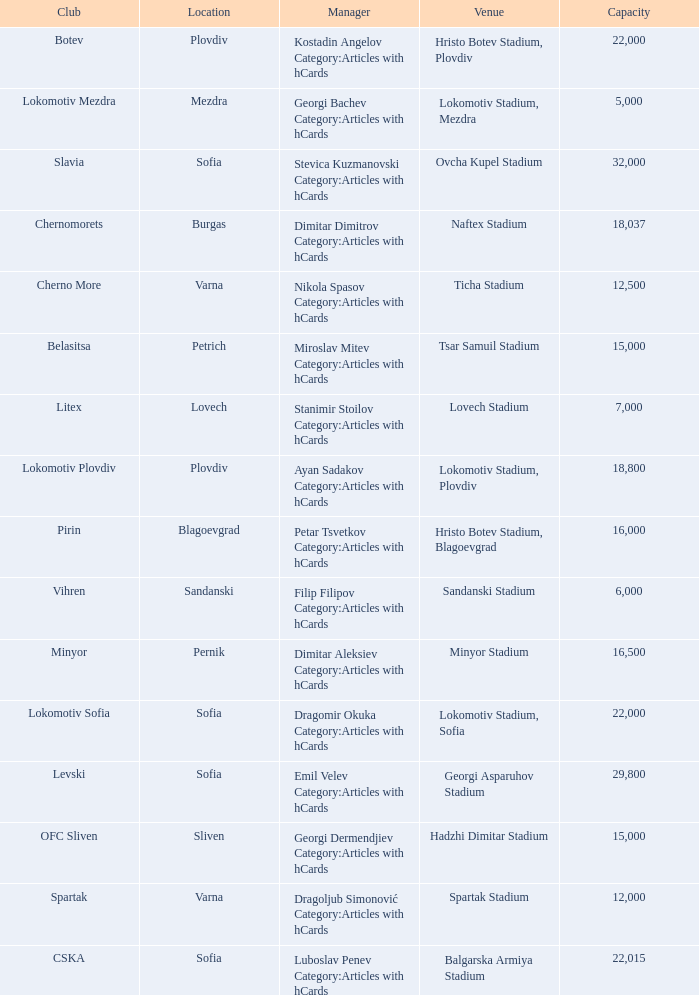What is the highest capacity for the venue, ticha stadium, located in varna? 12500.0. 